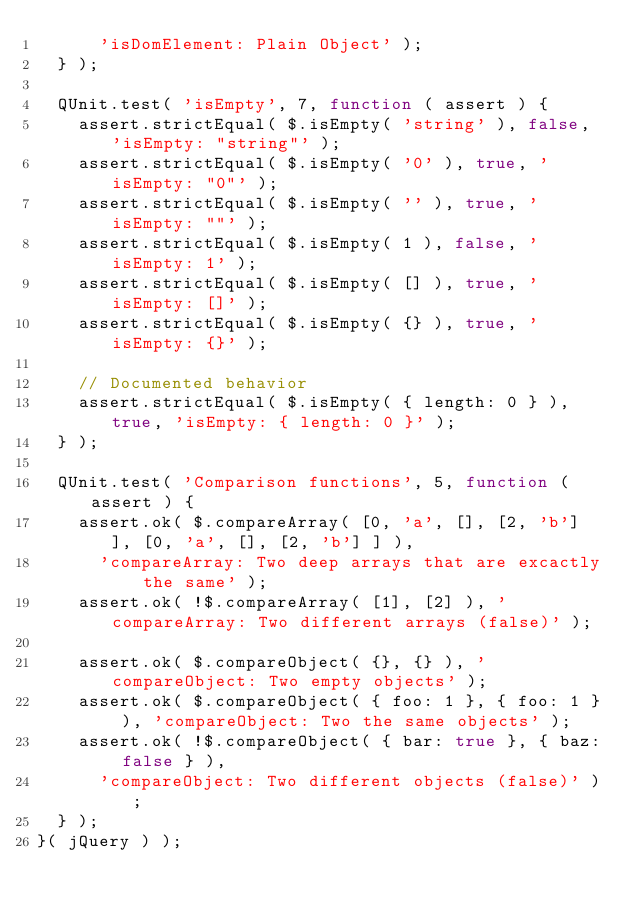<code> <loc_0><loc_0><loc_500><loc_500><_JavaScript_>			'isDomElement: Plain Object' );
	} );

	QUnit.test( 'isEmpty', 7, function ( assert ) {
		assert.strictEqual( $.isEmpty( 'string' ), false, 'isEmpty: "string"' );
		assert.strictEqual( $.isEmpty( '0' ), true, 'isEmpty: "0"' );
		assert.strictEqual( $.isEmpty( '' ), true, 'isEmpty: ""' );
		assert.strictEqual( $.isEmpty( 1 ), false, 'isEmpty: 1' );
		assert.strictEqual( $.isEmpty( [] ), true, 'isEmpty: []' );
		assert.strictEqual( $.isEmpty( {} ), true, 'isEmpty: {}' );

		// Documented behavior
		assert.strictEqual( $.isEmpty( { length: 0 } ), true, 'isEmpty: { length: 0 }' );
	} );

	QUnit.test( 'Comparison functions', 5, function ( assert ) {
		assert.ok( $.compareArray( [0, 'a', [], [2, 'b'] ], [0, 'a', [], [2, 'b'] ] ),
			'compareArray: Two deep arrays that are excactly the same' );
		assert.ok( !$.compareArray( [1], [2] ), 'compareArray: Two different arrays (false)' );

		assert.ok( $.compareObject( {}, {} ), 'compareObject: Two empty objects' );
		assert.ok( $.compareObject( { foo: 1 }, { foo: 1 } ), 'compareObject: Two the same objects' );
		assert.ok( !$.compareObject( { bar: true }, { baz: false } ),
			'compareObject: Two different objects (false)' );
	} );
}( jQuery ) );
</code> 